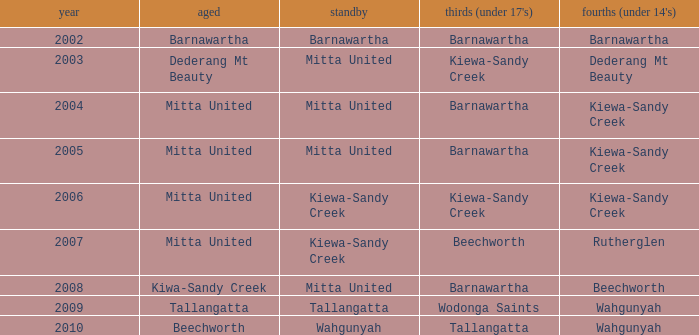Which Seniors have YEAR before 2006, and Fourths (Under 14's) of kiewa-sandy creek? Mitta United, Mitta United. 